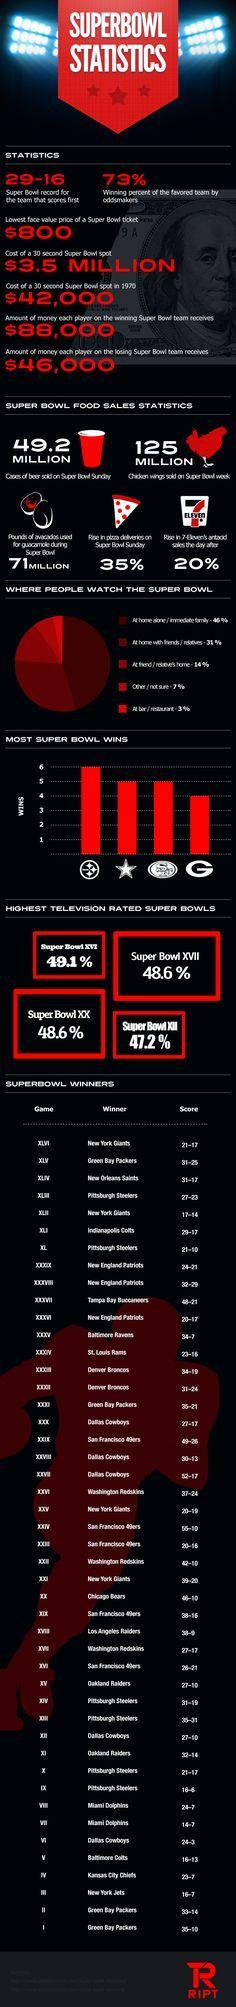What is the Super Bowl XVII Television rating?
Answer the question with a short phrase. 48.6 % What is the Super Bowl XX Television rating? 48.6 % What is the score of Super Bowl XLII? 17-14 Who won Super Bowl XV? Oakland Raiders Who won Super Bowl XLV? Green Bay Packers 